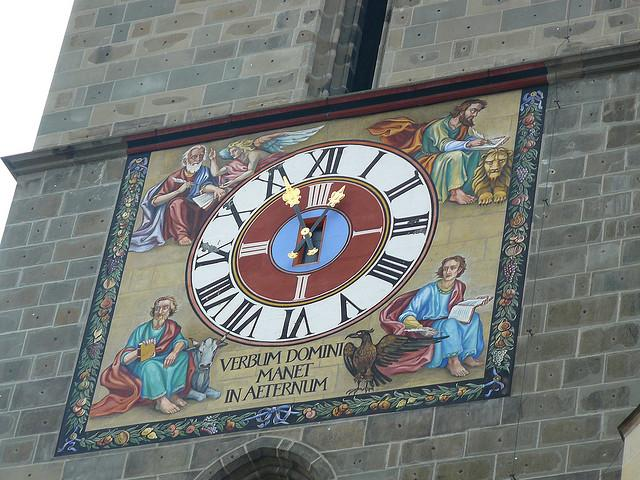What language are the words on the clock written in?

Choices:
A) greek
B) hebrew
C) latin
D) spanish latin 